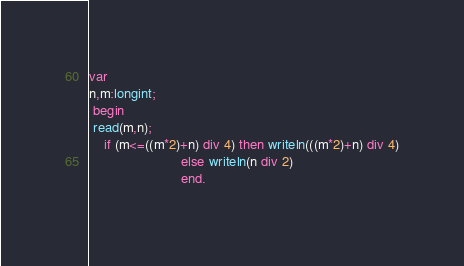<code> <loc_0><loc_0><loc_500><loc_500><_Pascal_>var
n,m:longint;
 begin
 read(m,n);
    if (m<=((m*2)+n) div 4) then writeln(((m*2)+n) div 4)
                        else writeln(n div 2)
                        end.
    </code> 